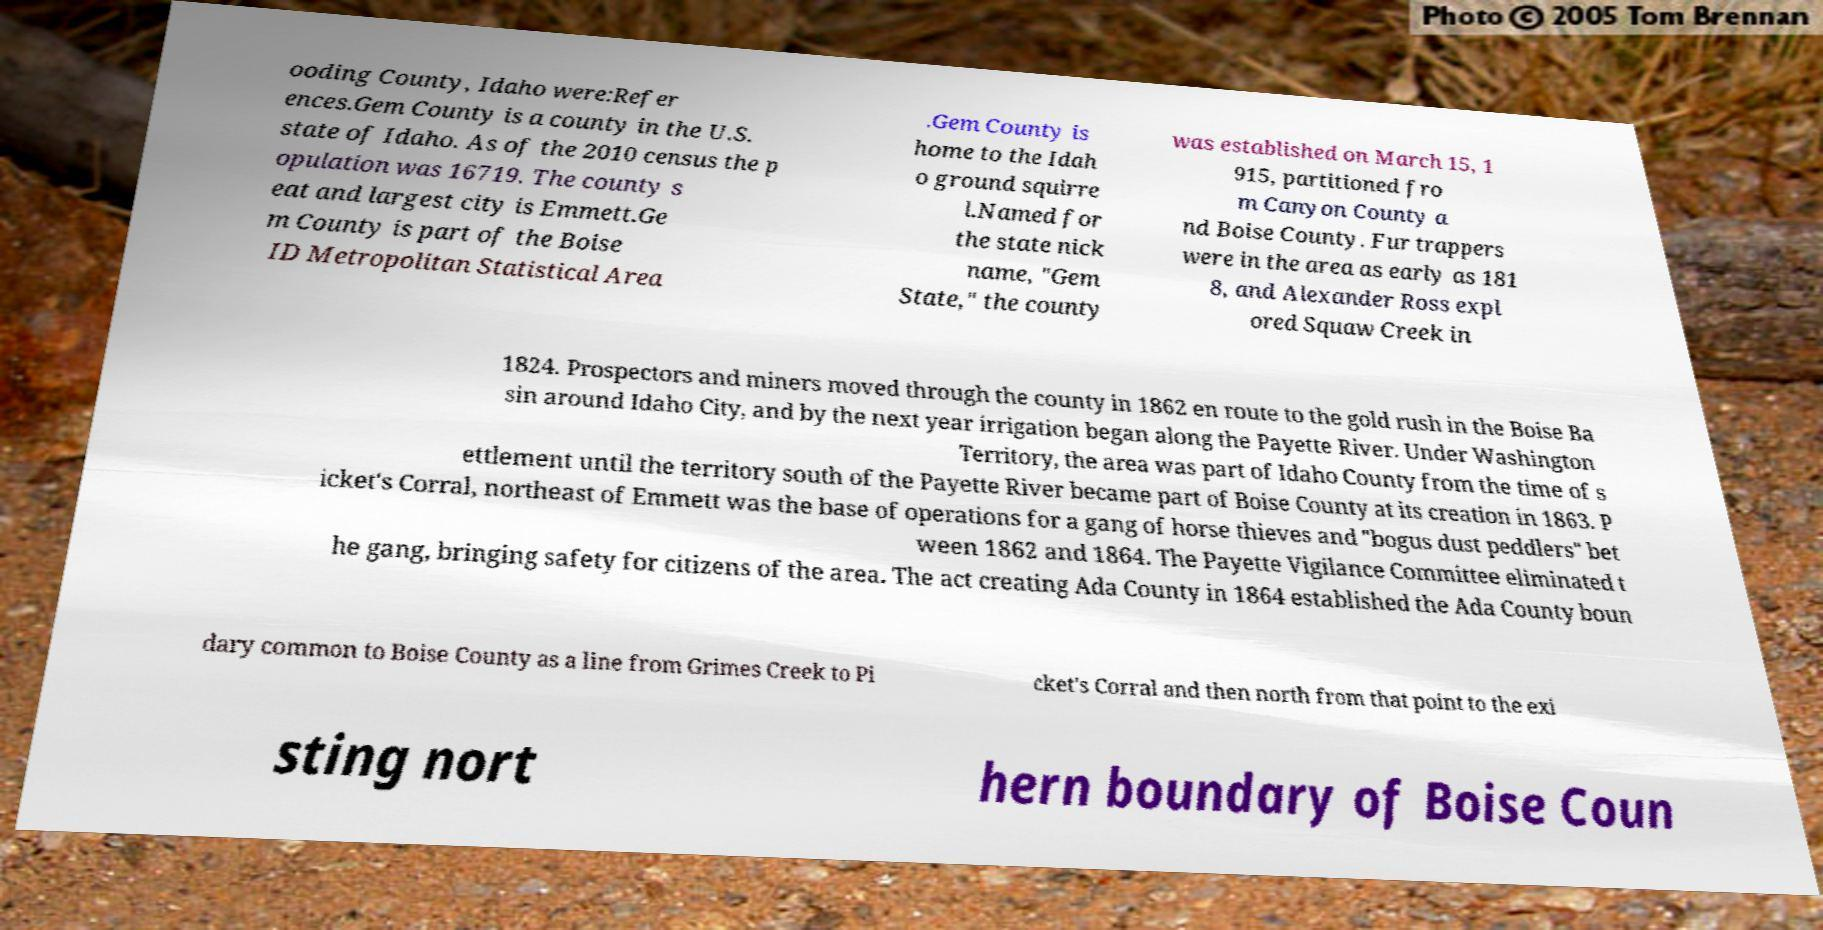Can you accurately transcribe the text from the provided image for me? ooding County, Idaho were:Refer ences.Gem County is a county in the U.S. state of Idaho. As of the 2010 census the p opulation was 16719. The county s eat and largest city is Emmett.Ge m County is part of the Boise ID Metropolitan Statistical Area .Gem County is home to the Idah o ground squirre l.Named for the state nick name, "Gem State," the county was established on March 15, 1 915, partitioned fro m Canyon County a nd Boise County. Fur trappers were in the area as early as 181 8, and Alexander Ross expl ored Squaw Creek in 1824. Prospectors and miners moved through the county in 1862 en route to the gold rush in the Boise Ba sin around Idaho City, and by the next year irrigation began along the Payette River. Under Washington Territory, the area was part of Idaho County from the time of s ettlement until the territory south of the Payette River became part of Boise County at its creation in 1863. P icket's Corral, northeast of Emmett was the base of operations for a gang of horse thieves and "bogus dust peddlers" bet ween 1862 and 1864. The Payette Vigilance Committee eliminated t he gang, bringing safety for citizens of the area. The act creating Ada County in 1864 established the Ada County boun dary common to Boise County as a line from Grimes Creek to Pi cket's Corral and then north from that point to the exi sting nort hern boundary of Boise Coun 